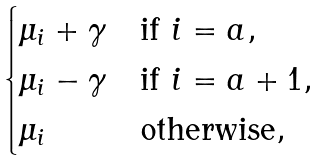<formula> <loc_0><loc_0><loc_500><loc_500>\begin{cases} \mu _ { i } + \gamma & \text {if } i = a , \\ \mu _ { i } - \gamma & \text {if } i = a + 1 , \\ \mu _ { i } & \text {otherwise} , \end{cases}</formula> 